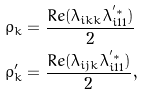Convert formula to latex. <formula><loc_0><loc_0><loc_500><loc_500>\rho _ { k } & = \frac { R e ( \lambda _ { i k k } \lambda _ { i 1 1 } ^ { ^ { \prime } * } ) } { 2 } \\ \rho ^ { \prime } _ { k } & = \frac { R e ( \lambda _ { i j k } \lambda _ { i 1 1 } ^ { ^ { \prime } * } ) } { 2 } ,</formula> 